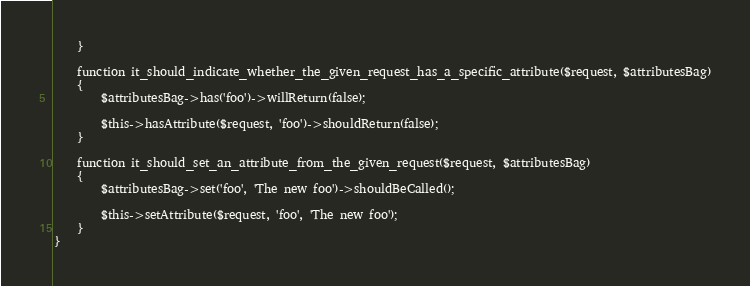Convert code to text. <code><loc_0><loc_0><loc_500><loc_500><_PHP_>    }

    function it_should_indicate_whether_the_given_request_has_a_specific_attribute($request, $attributesBag)
    {
        $attributesBag->has('foo')->willReturn(false);

        $this->hasAttribute($request, 'foo')->shouldReturn(false);
    }

    function it_should_set_an_attribute_from_the_given_request($request, $attributesBag)
    {
        $attributesBag->set('foo', 'The new foo')->shouldBeCalled();

        $this->setAttribute($request, 'foo', 'The new foo');
    }
}
</code> 